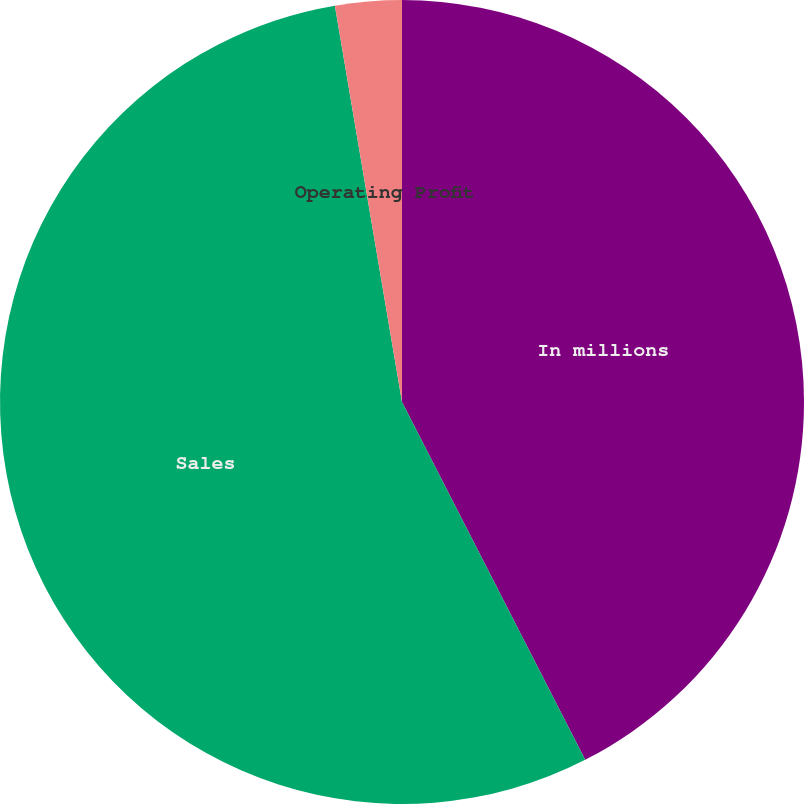<chart> <loc_0><loc_0><loc_500><loc_500><pie_chart><fcel>In millions<fcel>Sales<fcel>Operating Profit<nl><fcel>42.47%<fcel>54.86%<fcel>2.67%<nl></chart> 